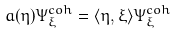Convert formula to latex. <formula><loc_0><loc_0><loc_500><loc_500>a ( \eta ) \Psi ^ { c o h } _ { \xi } = \langle \eta , \xi \rangle \Psi ^ { c o h } _ { \xi }</formula> 